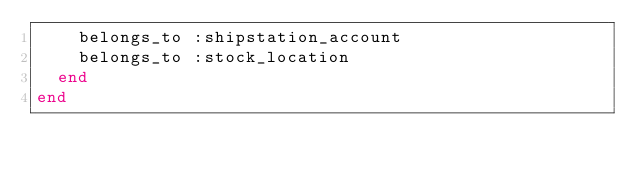<code> <loc_0><loc_0><loc_500><loc_500><_Ruby_>    belongs_to :shipstation_account
    belongs_to :stock_location
  end
end
</code> 